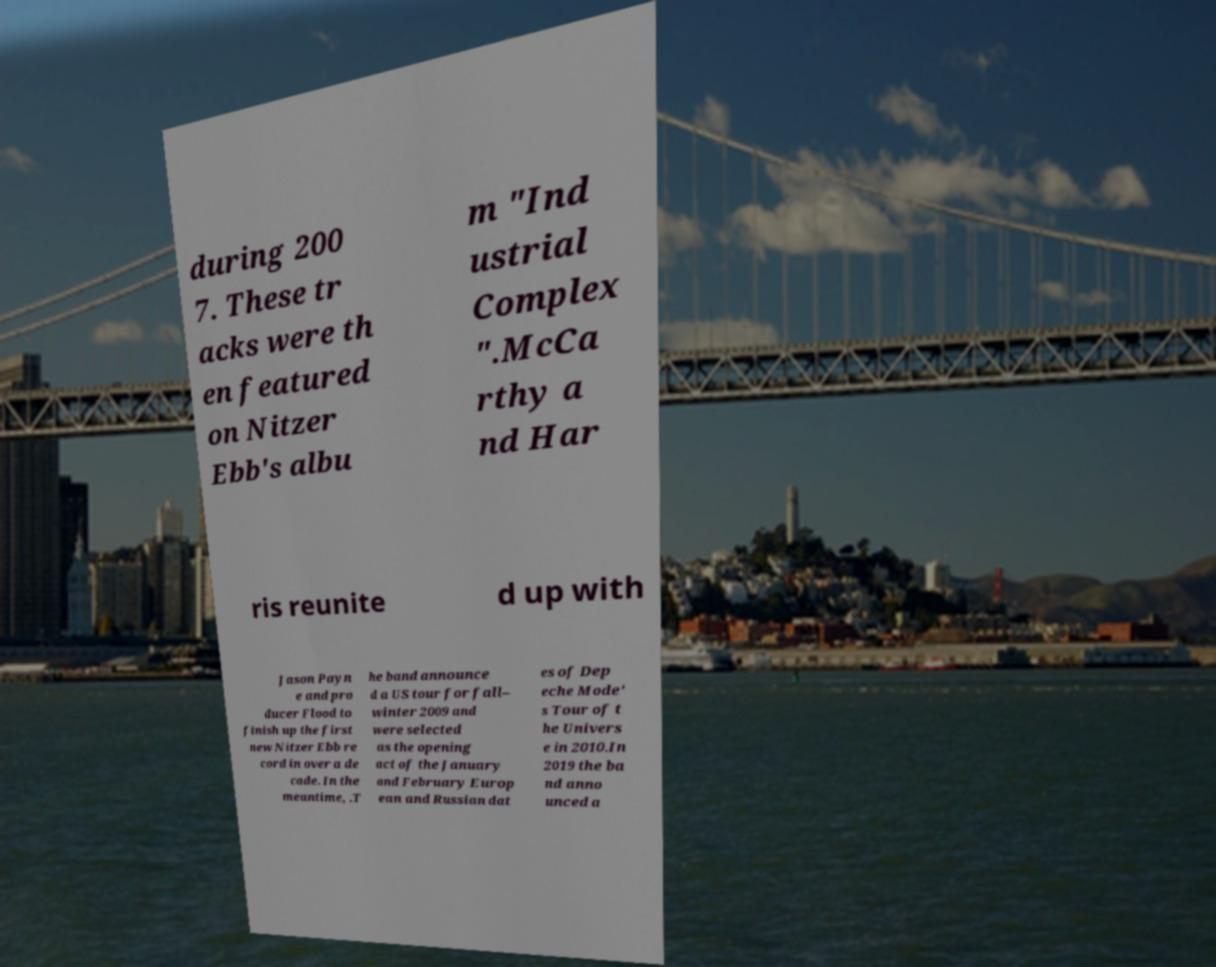What messages or text are displayed in this image? I need them in a readable, typed format. during 200 7. These tr acks were th en featured on Nitzer Ebb's albu m "Ind ustrial Complex ".McCa rthy a nd Har ris reunite d up with Jason Payn e and pro ducer Flood to finish up the first new Nitzer Ebb re cord in over a de cade. In the meantime, .T he band announce d a US tour for fall– winter 2009 and were selected as the opening act of the January and February Europ ean and Russian dat es of Dep eche Mode' s Tour of t he Univers e in 2010.In 2019 the ba nd anno unced a 